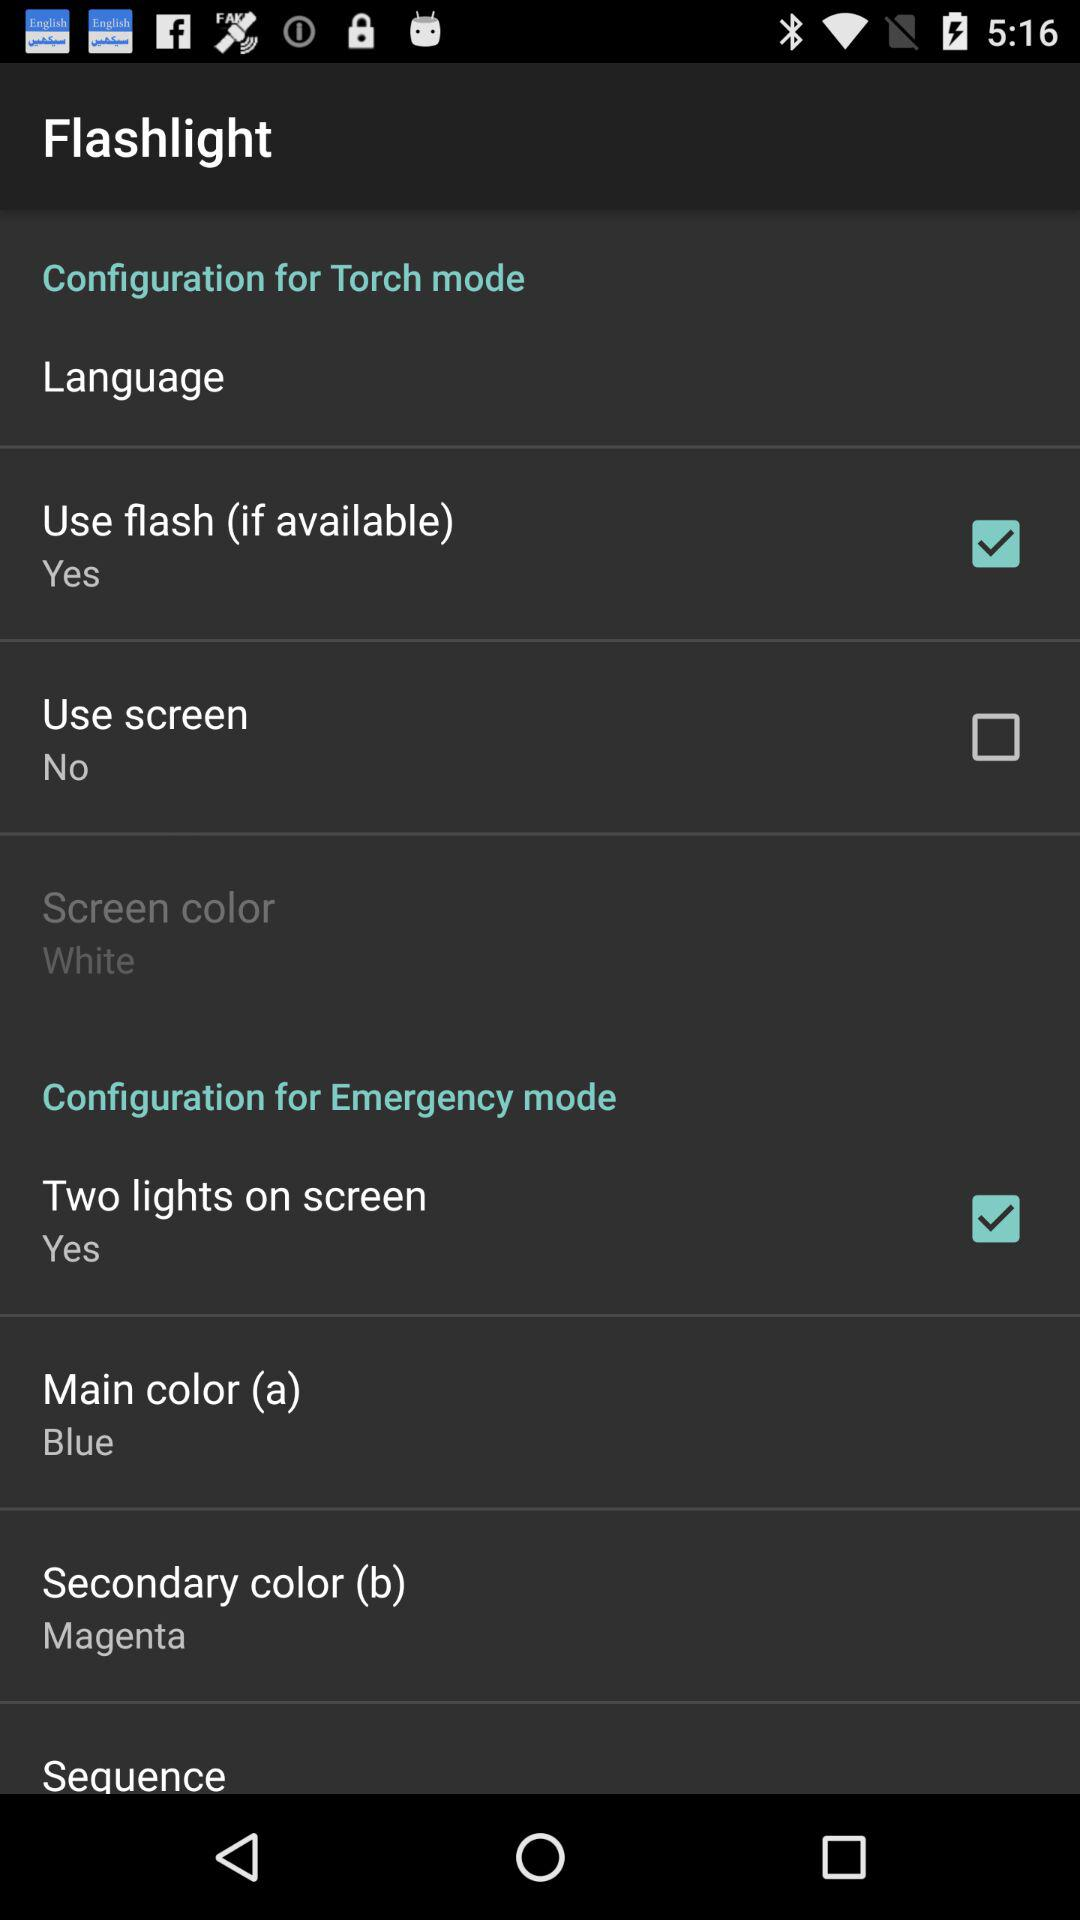What is the status of "Two lights on screen"? The status is "on". 